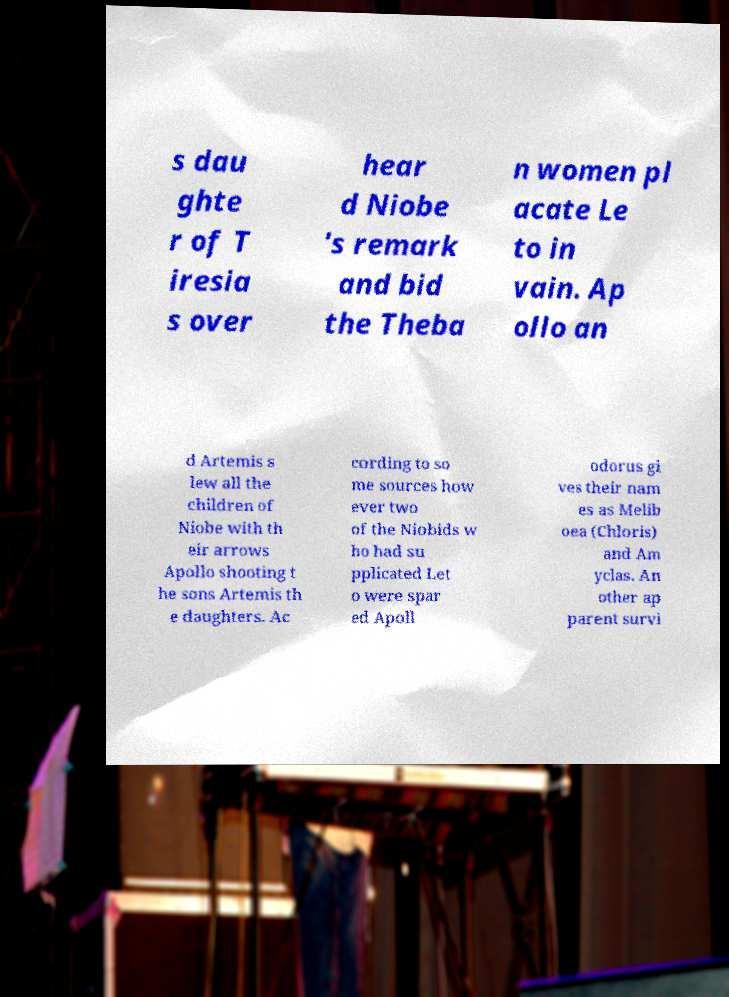Please identify and transcribe the text found in this image. s dau ghte r of T iresia s over hear d Niobe 's remark and bid the Theba n women pl acate Le to in vain. Ap ollo an d Artemis s lew all the children of Niobe with th eir arrows Apollo shooting t he sons Artemis th e daughters. Ac cording to so me sources how ever two of the Niobids w ho had su pplicated Let o were spar ed Apoll odorus gi ves their nam es as Melib oea (Chloris) and Am yclas. An other ap parent survi 